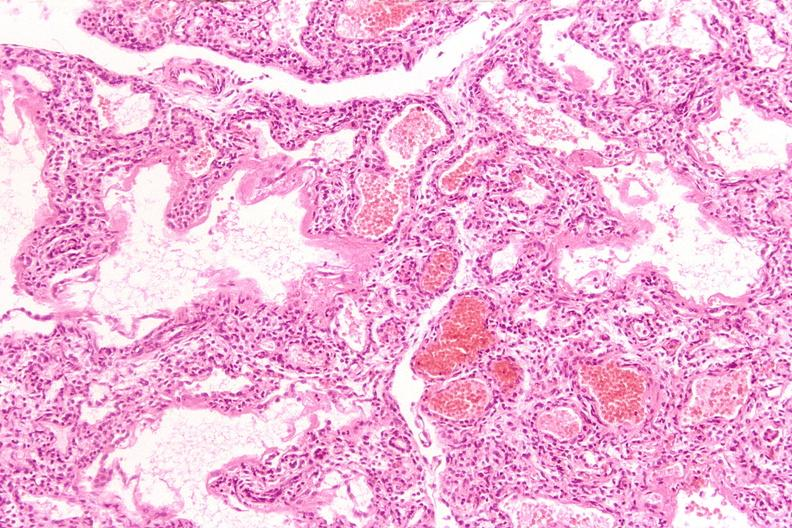where is this?
Answer the question using a single word or phrase. Lung 